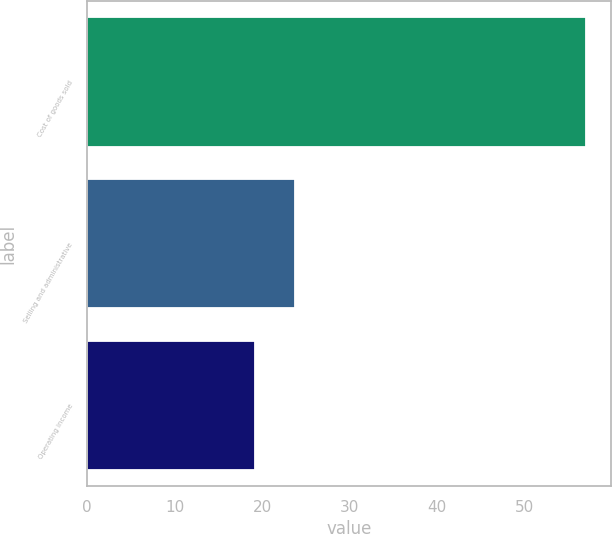Convert chart. <chart><loc_0><loc_0><loc_500><loc_500><bar_chart><fcel>Cost of goods sold<fcel>Selling and administrative<fcel>Operating income<nl><fcel>57<fcel>23.7<fcel>19.2<nl></chart> 